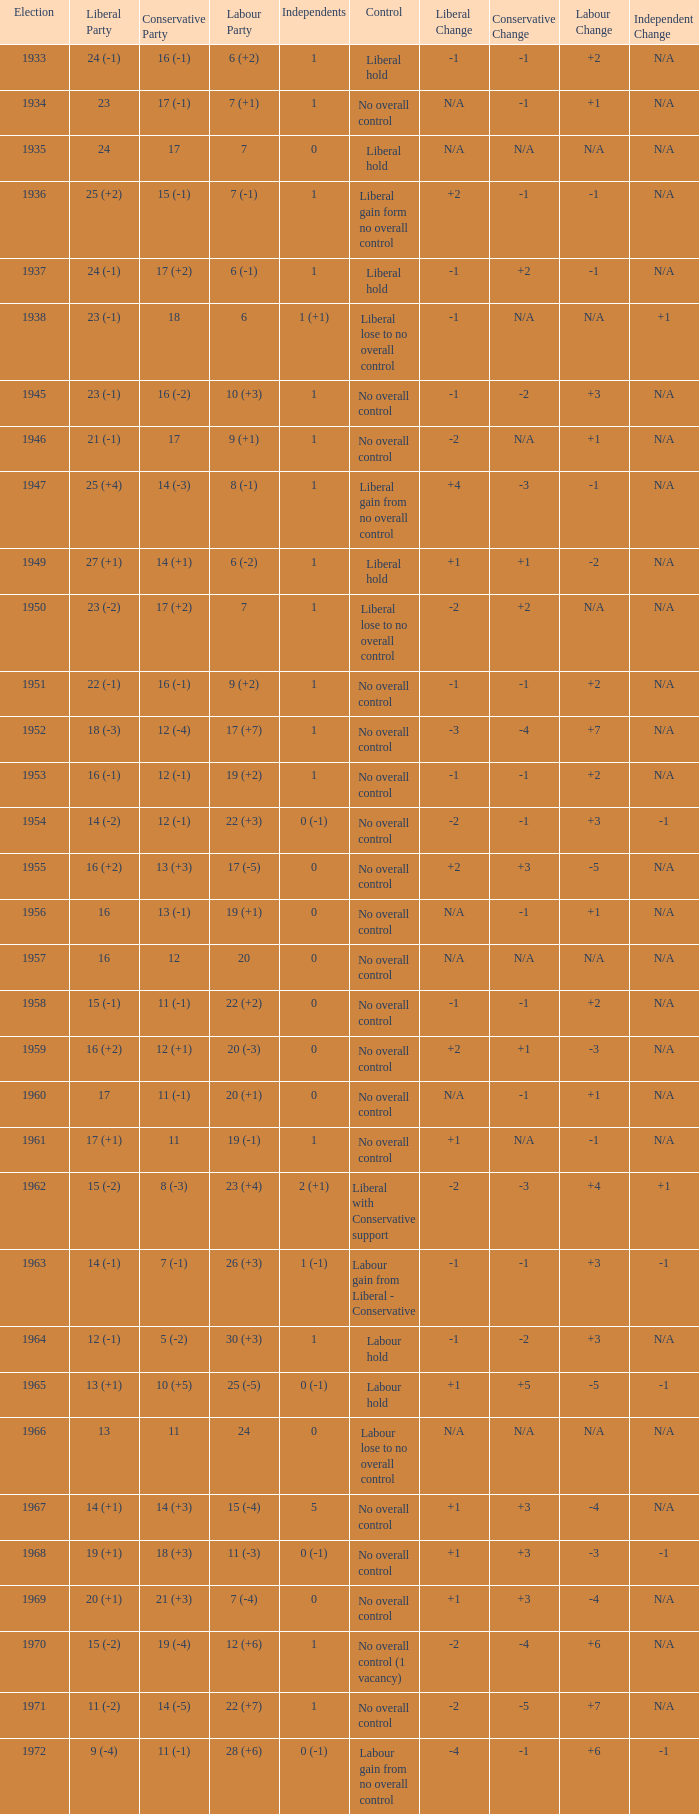What is the number of Independents elected in the year Labour won 26 (+3) seats? 1 (-1). 